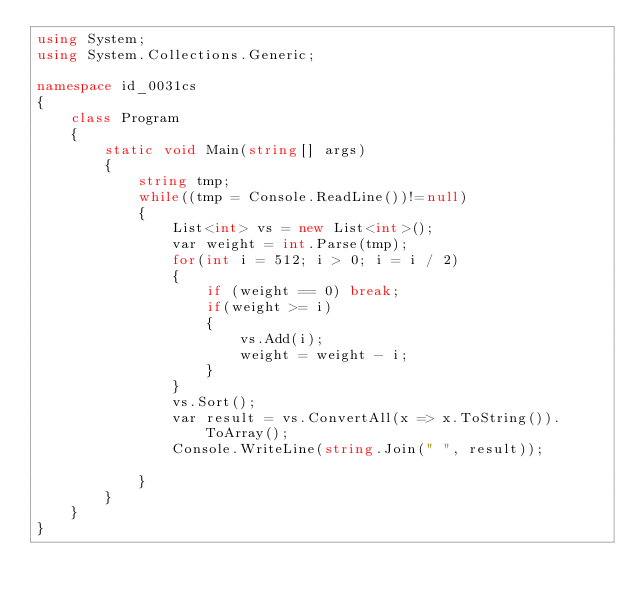Convert code to text. <code><loc_0><loc_0><loc_500><loc_500><_C#_>using System;
using System.Collections.Generic;

namespace id_0031cs
{
    class Program
    {
        static void Main(string[] args)
        {
            string tmp;
            while((tmp = Console.ReadLine())!=null)
            {
                List<int> vs = new List<int>();
                var weight = int.Parse(tmp);
                for(int i = 512; i > 0; i = i / 2)
                {
                    if (weight == 0) break;
                    if(weight >= i)
                    {
                        vs.Add(i);
                        weight = weight - i;
                    }
                }
                vs.Sort();
                var result = vs.ConvertAll(x => x.ToString()).ToArray();
                Console.WriteLine(string.Join(" ", result));

            }
        }
    }
}

</code> 